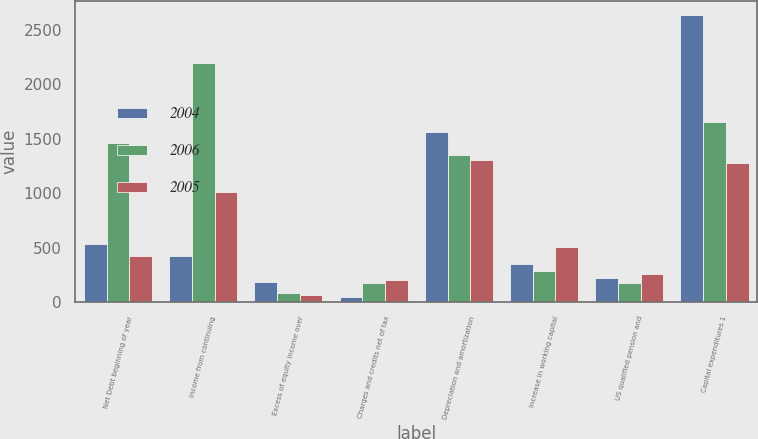<chart> <loc_0><loc_0><loc_500><loc_500><stacked_bar_chart><ecel><fcel>Net Debt beginning of year<fcel>Income from continuing<fcel>Excess of equity income over<fcel>Charges and credits net of tax<fcel>Depreciation and amortization<fcel>Increase in working capital<fcel>US qualified pension and<fcel>Capital expenditures 1<nl><fcel>2004<fcel>532<fcel>426.5<fcel>181<fcel>43<fcel>1561<fcel>351<fcel>225<fcel>2637<nl><fcel>2006<fcel>1459<fcel>2199<fcel>86<fcel>173<fcel>1351<fcel>286<fcel>172<fcel>1652<nl><fcel>2005<fcel>426.5<fcel>1014<fcel>66<fcel>199<fcel>1308<fcel>502<fcel>254<fcel>1279<nl></chart> 